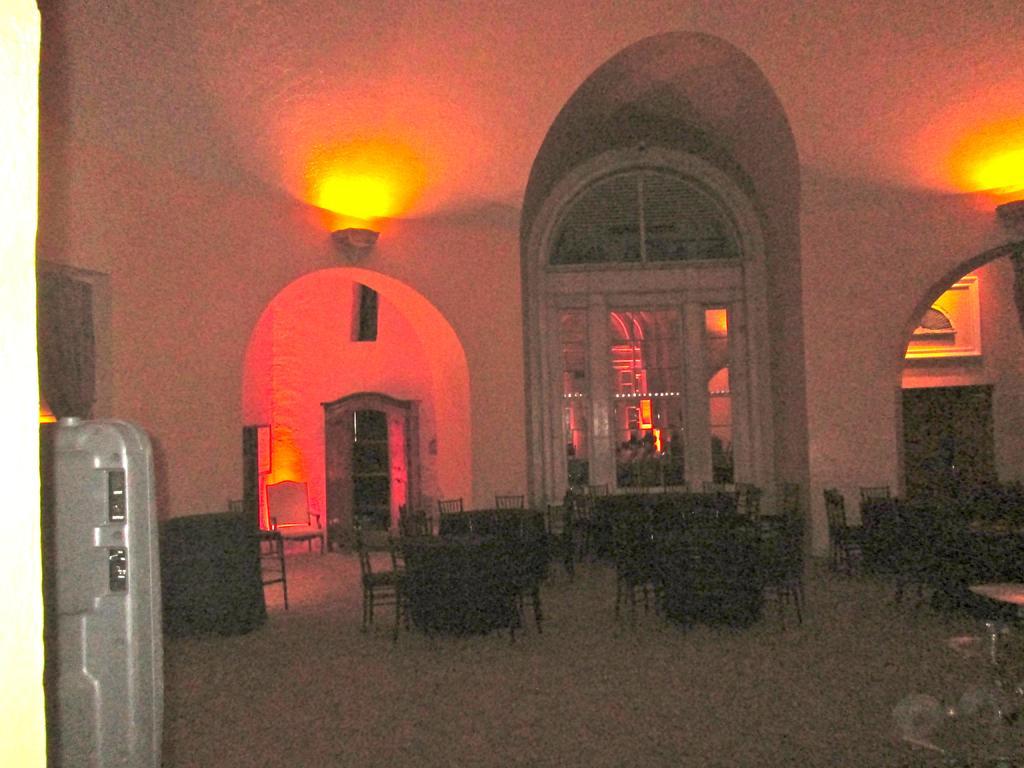Could you give a brief overview of what you see in this image? This is an inside view of a building and here we can see tables, chairs, lights, a cupboard, refrigerator and some other objects. At the bottom, there is a floor and at the top, there is a roof. 